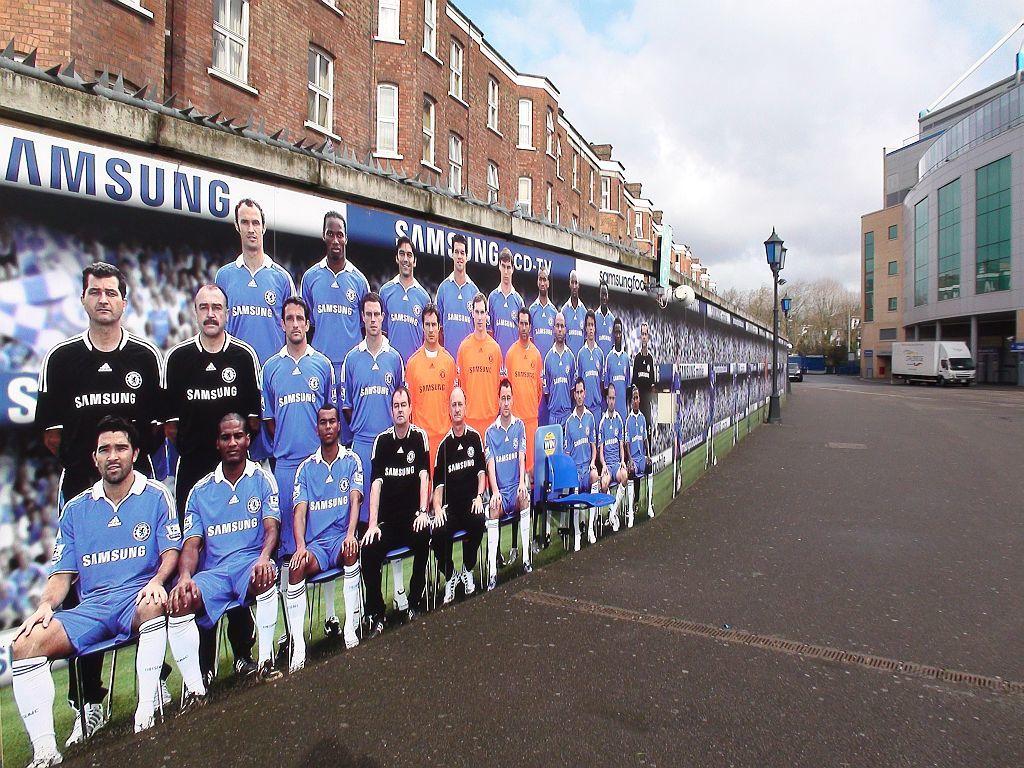Which company sponsors this team?
Provide a short and direct response. Samsung. 